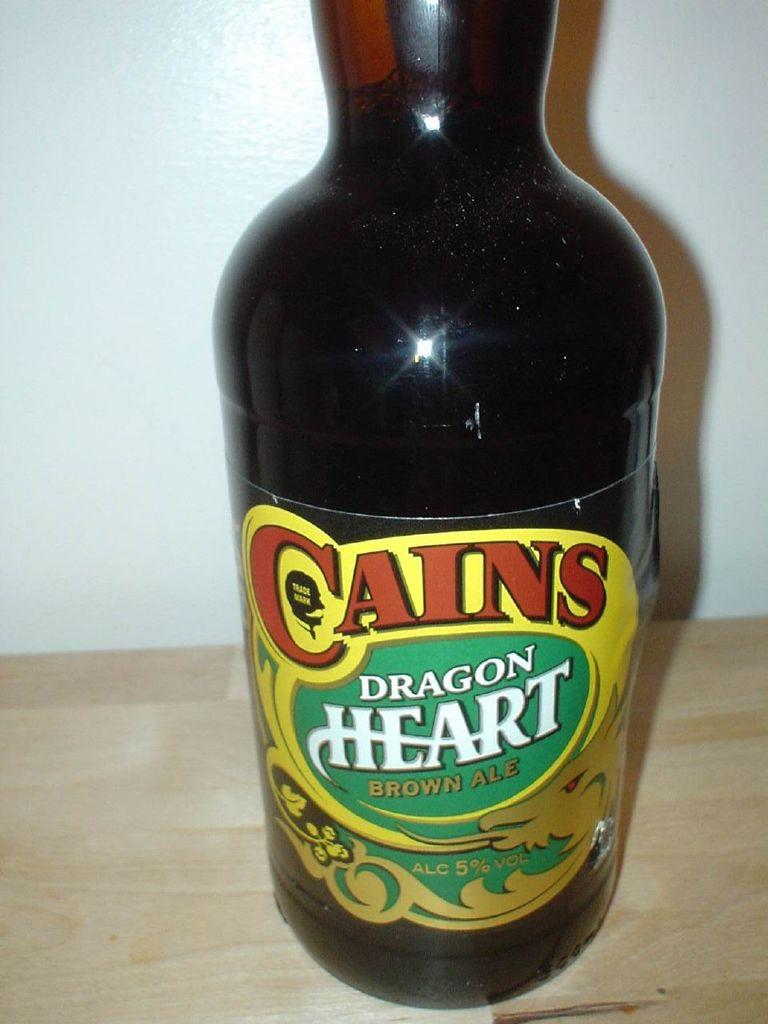<image>
Share a concise interpretation of the image provided. A BOTTLE OF BROWN ALE NAMED CAINS DRAGON HEART 